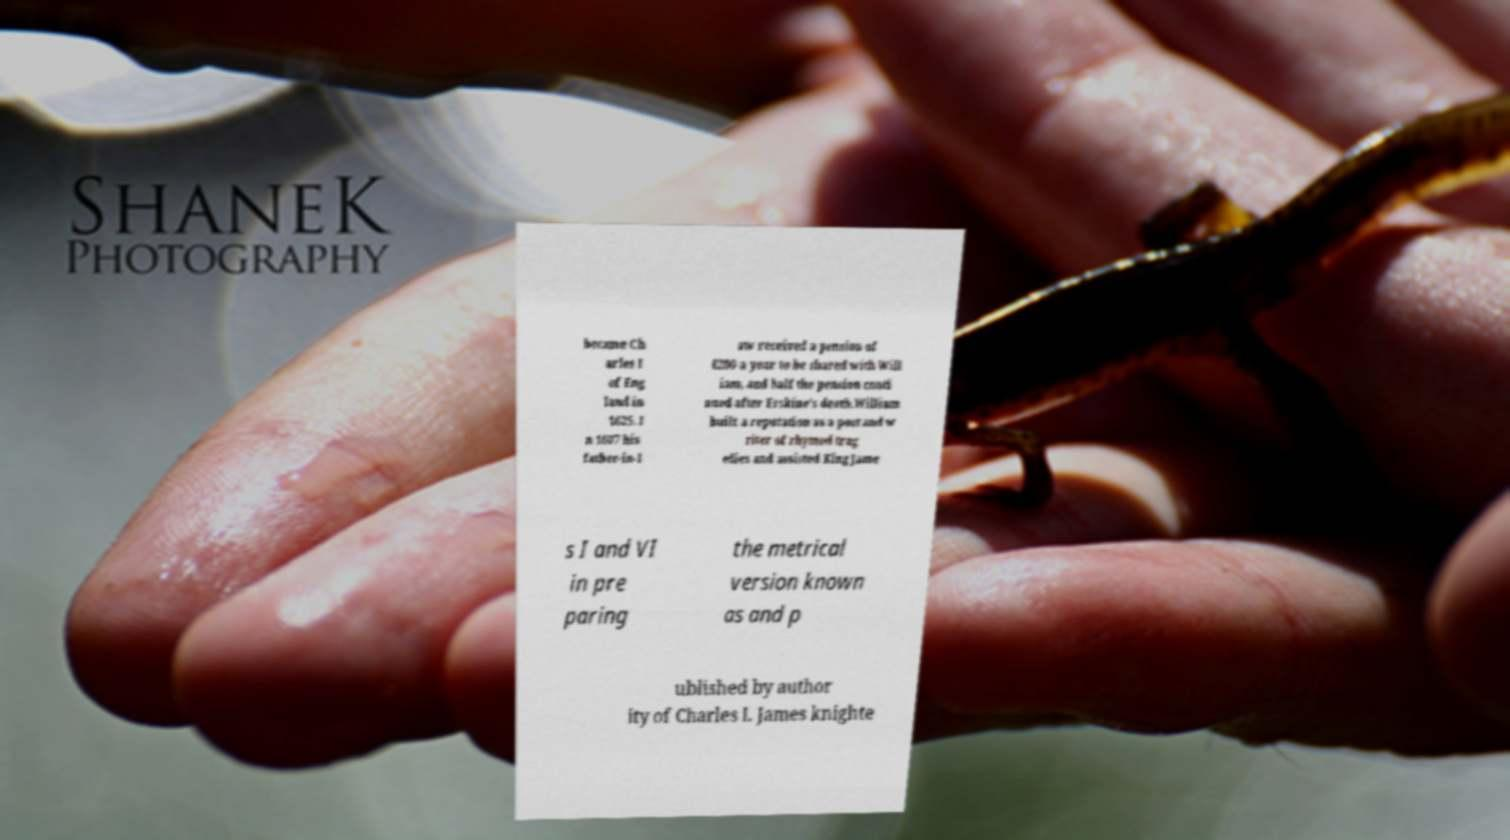There's text embedded in this image that I need extracted. Can you transcribe it verbatim? became Ch arles I of Eng land in 1625. I n 1607 his father-in-l aw received a pension of £200 a year to be shared with Will iam, and half the pension conti nued after Erskine's death.William built a reputation as a poet and w riter of rhymed trag edies and assisted King Jame s I and VI in pre paring the metrical version known as and p ublished by author ity of Charles I. James knighte 